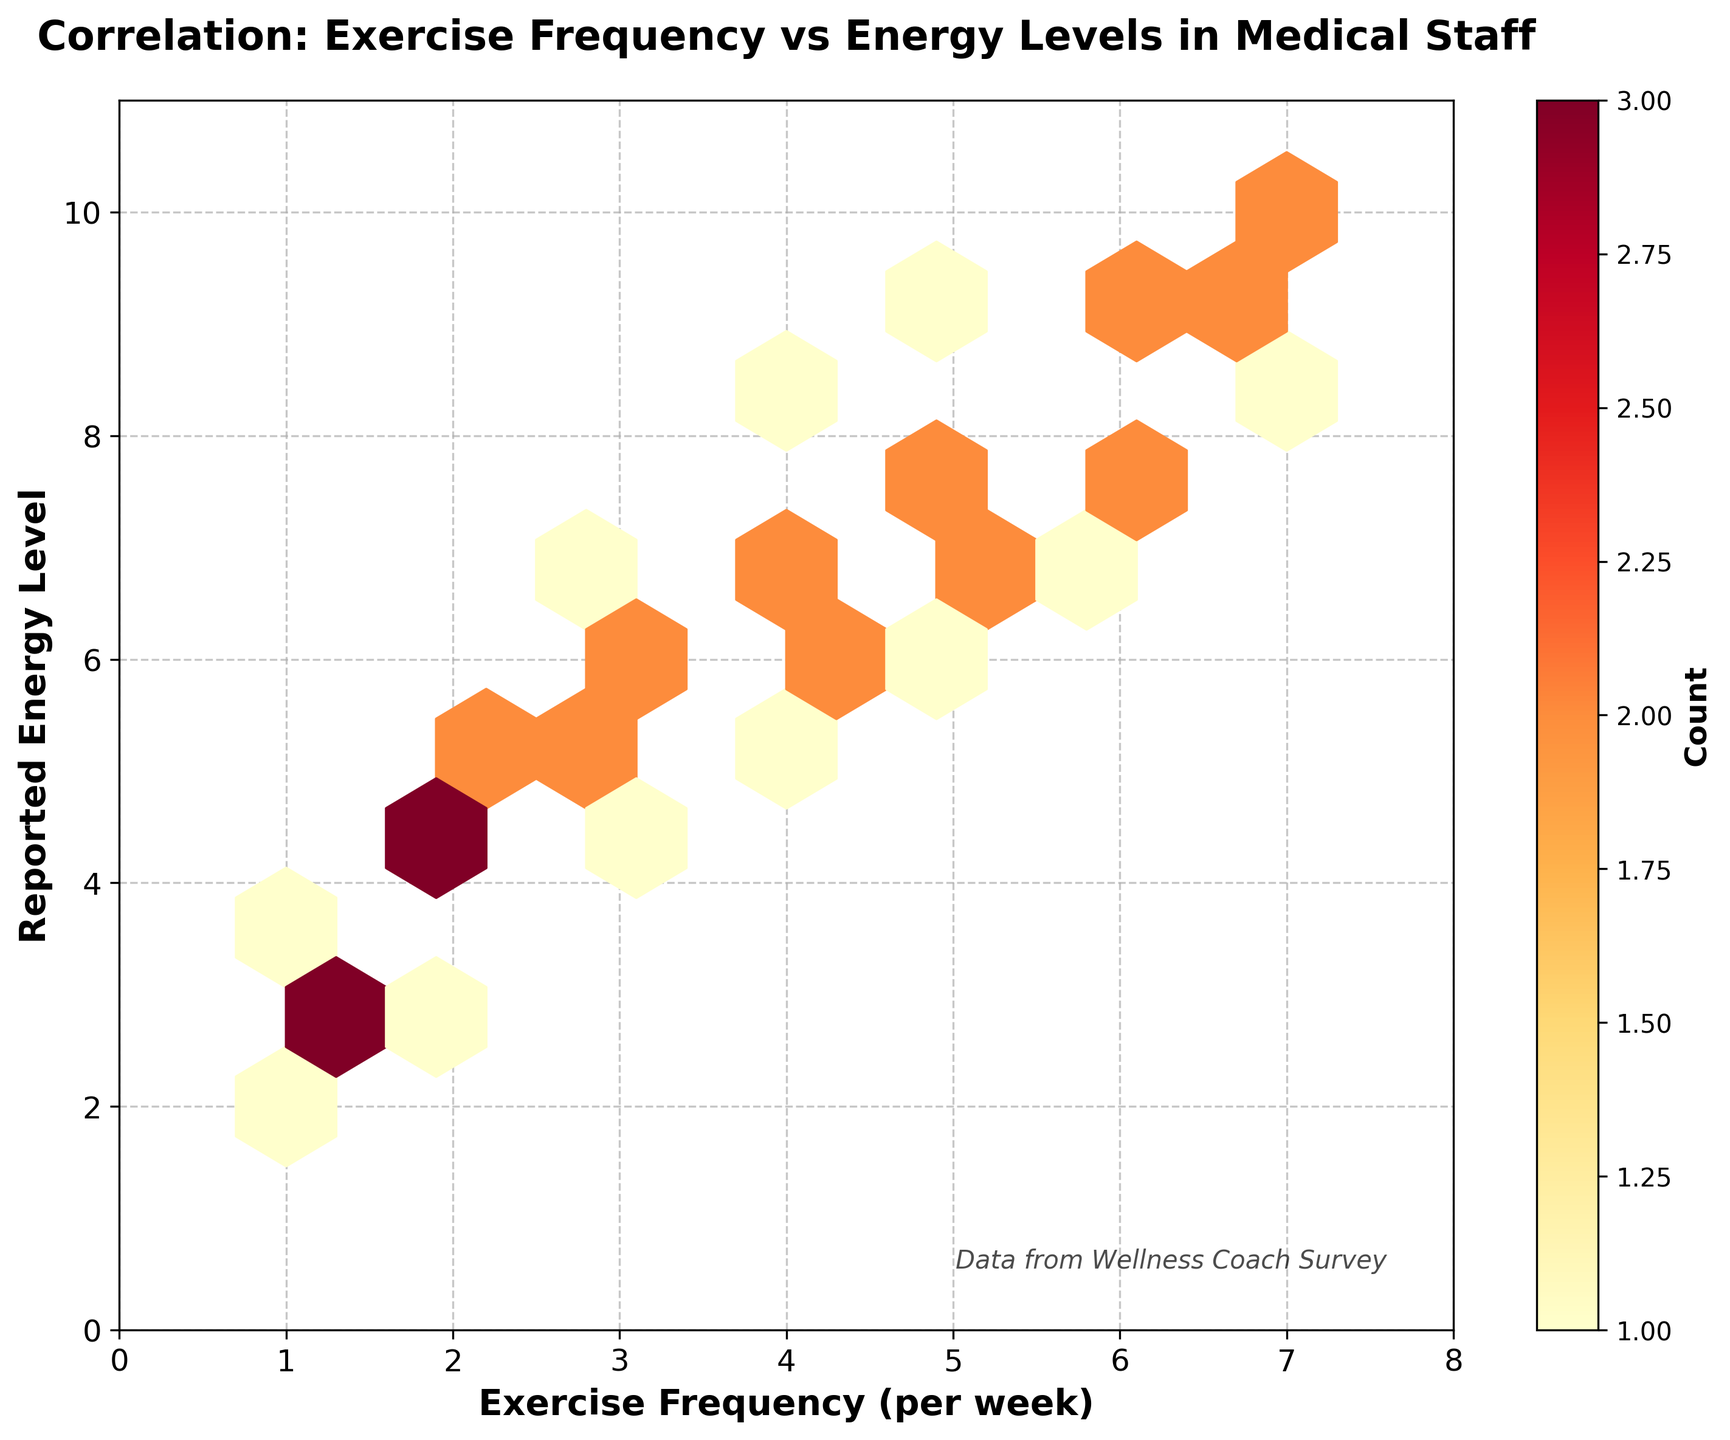What is the title of the figure? The title of the figure can be found at the top of the plot. It states: 'Correlation: Exercise Frequency vs Energy Levels in Medical Staff'
Answer: Correlation: Exercise Frequency vs Energy Levels in Medical Staff What are the labels on the x-axis and y-axis? The labels can be seen directly adjacent to each axis. The x-axis is labeled 'Exercise Frequency (per week)' and the y-axis is labeled 'Reported Energy Level'
Answer: Exercise Frequency (per week); Reported Energy Level What is the range of the x-axis? The x-axis range can be observed from the axis bounds. It starts from 0 and ends at 8
Answer: 0 to 8 How many color intensity levels are there in the hexbin plot? The color intensity levels in the hexbin plot can be observed from the color bar, indicating different counts. The color bar shows transitions from lighter to darker shades
Answer: Multiple shades (Density of points) What's the highest recorded energy level and its corresponding exercise frequency? The highest energy level is observed on the y-axis at 10. The corresponding exercise frequency, marked on the x-axis, is 7
Answer: Energy Level 10 at Exercise Frequency 7 Which exercise frequency category has the highest concentration of reported energy levels? The highest concentration can be determined from the brightest hexbin, which indicates more overlapping data points. This appears around the frequency of 3 to 5 per week
Answer: 3 to 5 per week Is there a general trend observable between exercise frequency and reported energy levels? The general trend can be inferred by looking at how the hexags are distributed (moving from lower left to upper right). Higher exercise frequencies generally correlate with higher energy levels
Answer: Positive correlation What does the color bar represent? The color bar beside the plot indicates the count of data points within each hexagonal bin. This helps to understand the density of occurrences
Answer: Count of data points Are there more data points reported with an energy level above or below 5? The visual plot shows more overlapping hexagons on the range above 5 on the y-axis compared to below it
Answer: Above 5 What is the relation between energy levels at an exercise frequency of 4 per week? By observing data points at an exercise frequency of 4, the bins are concentrated mostly between levels 6 to 7
Answer: Primarily between 6 to 7 